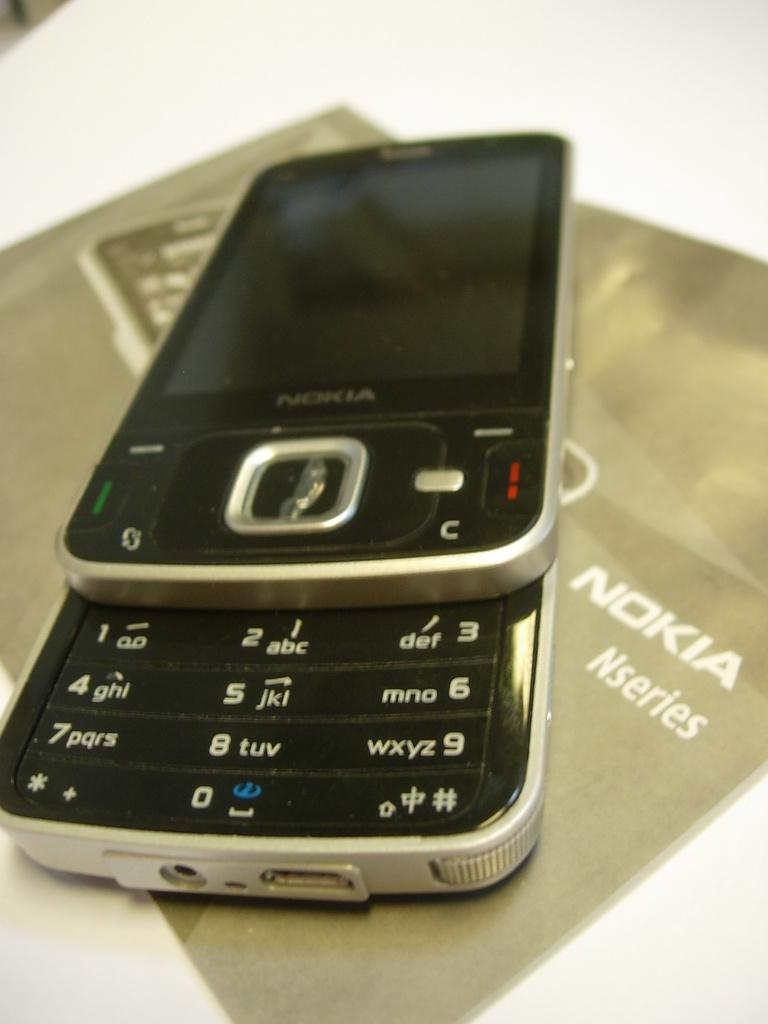<image>
Describe the image concisely. a Nokia mouse pad that has white behind it 